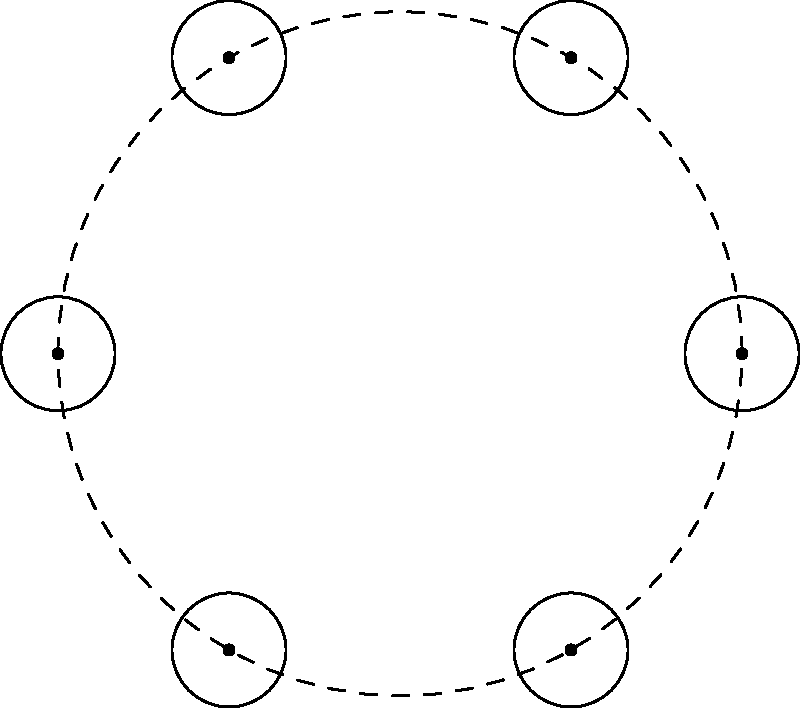In a hospital operating room, six identical medical devices are arranged in a circular pattern around a central point, as shown in the diagram. Each device can be rotated around its own axis or reflected across a line passing through the center. How many different symmetry operations (including the identity) can be performed on this arrangement while leaving it visually unchanged? To solve this problem, we need to consider the symmetry group of the arrangement. Let's break it down step by step:

1. Rotational symmetry:
   - The arrangement has 6-fold rotational symmetry.
   - This means we can rotate the entire arrangement by multiples of 60° (360°/6).
   - There are 6 possible rotations: 0°, 60°, 120°, 180°, 240°, 300°.

2. Reflection symmetry:
   - There are 6 lines of reflection, each passing through the center and a device.
   - These reflections create 6 different symmetry operations.

3. Combined operations:
   - Each reflection can be combined with each rotation to create a new symmetry operation.
   - However, these combinations don't create any new unique arrangements.

4. Identity operation:
   - The identity operation (doing nothing) is already counted in the rotational symmetry (0° rotation).

5. Calculating the total number of symmetry operations:
   - Total = Rotations + Reflections
   - Total = 6 + 6 = 12

Therefore, there are 12 different symmetry operations that can be performed on this arrangement while leaving it visually unchanged.

This group of symmetry operations is known as the dihedral group $D_6$, which has order 12.
Answer: 12 symmetry operations 